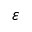<formula> <loc_0><loc_0><loc_500><loc_500>\varepsilon</formula> 